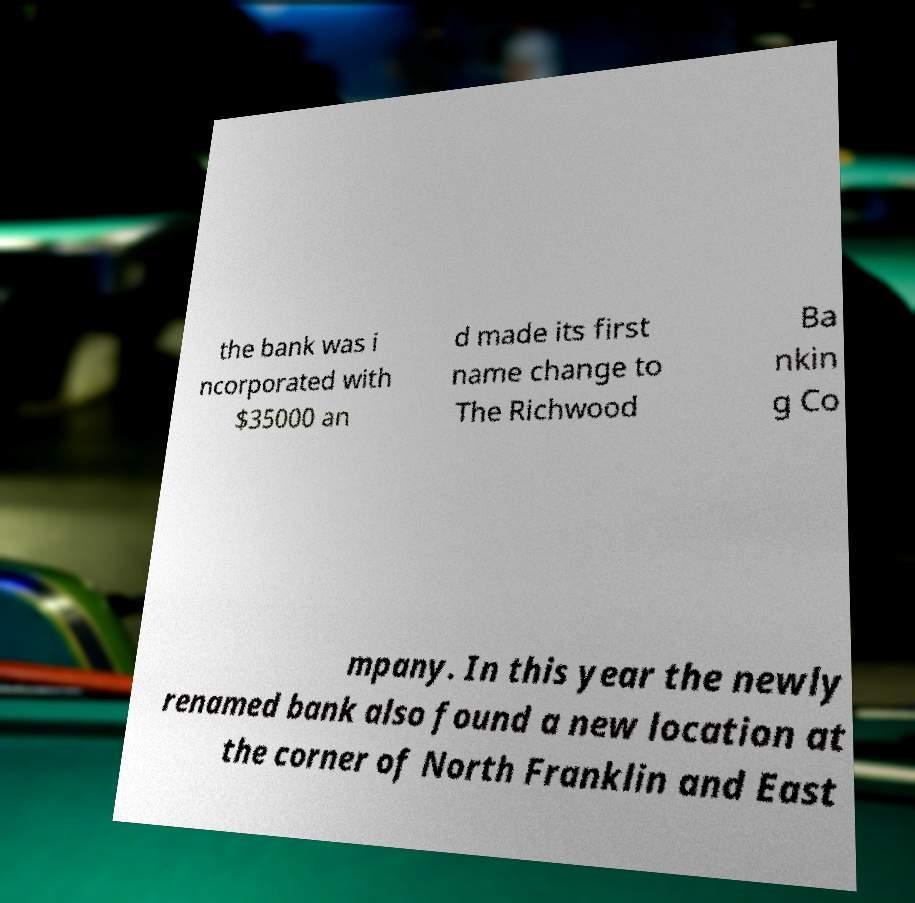Can you accurately transcribe the text from the provided image for me? the bank was i ncorporated with $35000 an d made its first name change to The Richwood Ba nkin g Co mpany. In this year the newly renamed bank also found a new location at the corner of North Franklin and East 